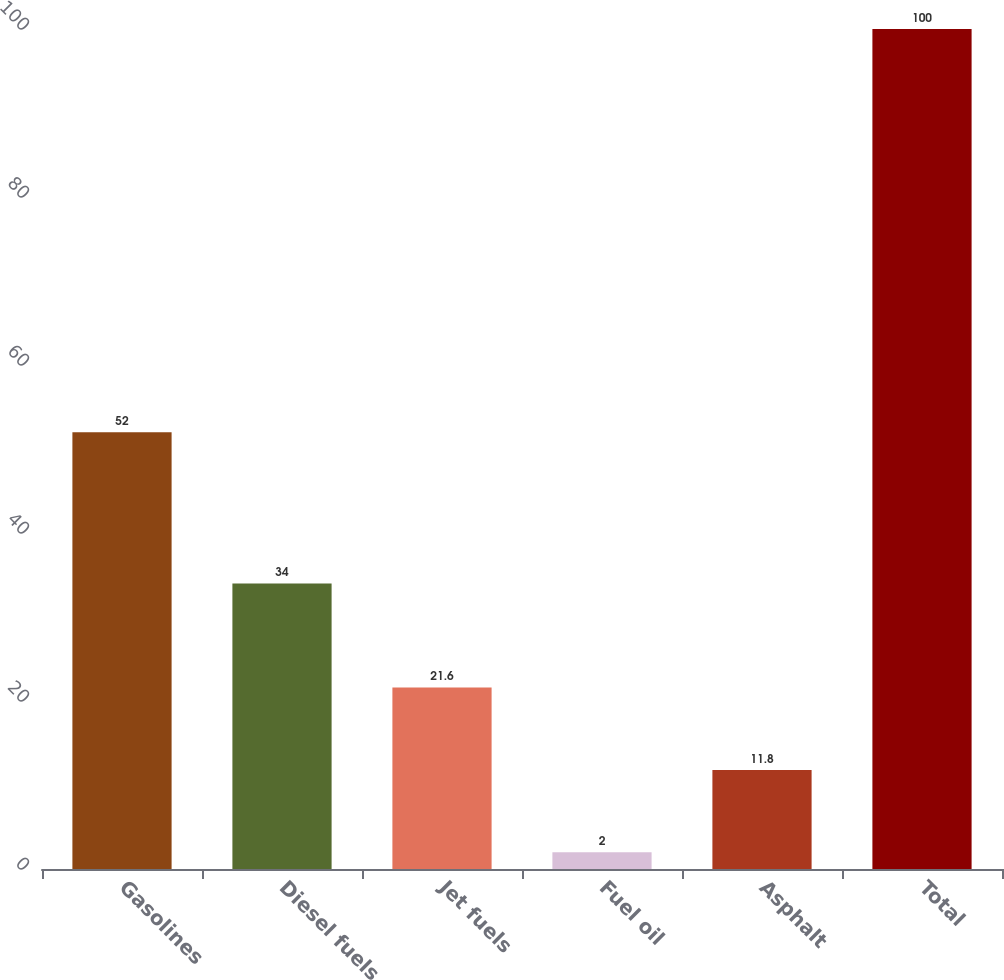Convert chart. <chart><loc_0><loc_0><loc_500><loc_500><bar_chart><fcel>Gasolines<fcel>Diesel fuels<fcel>Jet fuels<fcel>Fuel oil<fcel>Asphalt<fcel>Total<nl><fcel>52<fcel>34<fcel>21.6<fcel>2<fcel>11.8<fcel>100<nl></chart> 